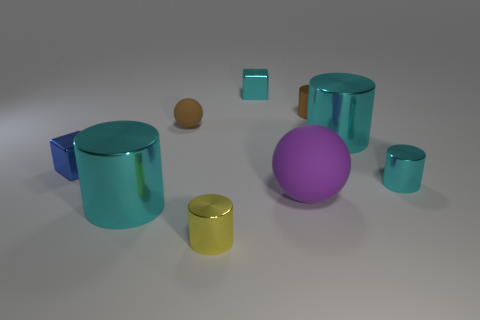Subtract all cyan cylinders. How many were subtracted if there are1cyan cylinders left? 2 Subtract all green cubes. How many cyan cylinders are left? 3 Subtract 1 cylinders. How many cylinders are left? 4 Subtract all brown cylinders. How many cylinders are left? 4 Subtract all small yellow cylinders. How many cylinders are left? 4 Subtract all blue cylinders. Subtract all red cubes. How many cylinders are left? 5 Add 1 tiny green metallic cylinders. How many objects exist? 10 Subtract all cylinders. How many objects are left? 4 Add 4 small shiny things. How many small shiny things are left? 9 Add 8 big matte spheres. How many big matte spheres exist? 9 